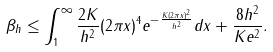<formula> <loc_0><loc_0><loc_500><loc_500>\beta _ { h } \leq \int _ { 1 } ^ { \infty } \frac { 2 K } { h ^ { 2 } } ( 2 \pi x ) ^ { 4 } e ^ { - \frac { K ( 2 \pi x ) ^ { 2 } } { h ^ { 2 } } } d x + \frac { 8 h ^ { 2 } } { K e ^ { 2 } } .</formula> 